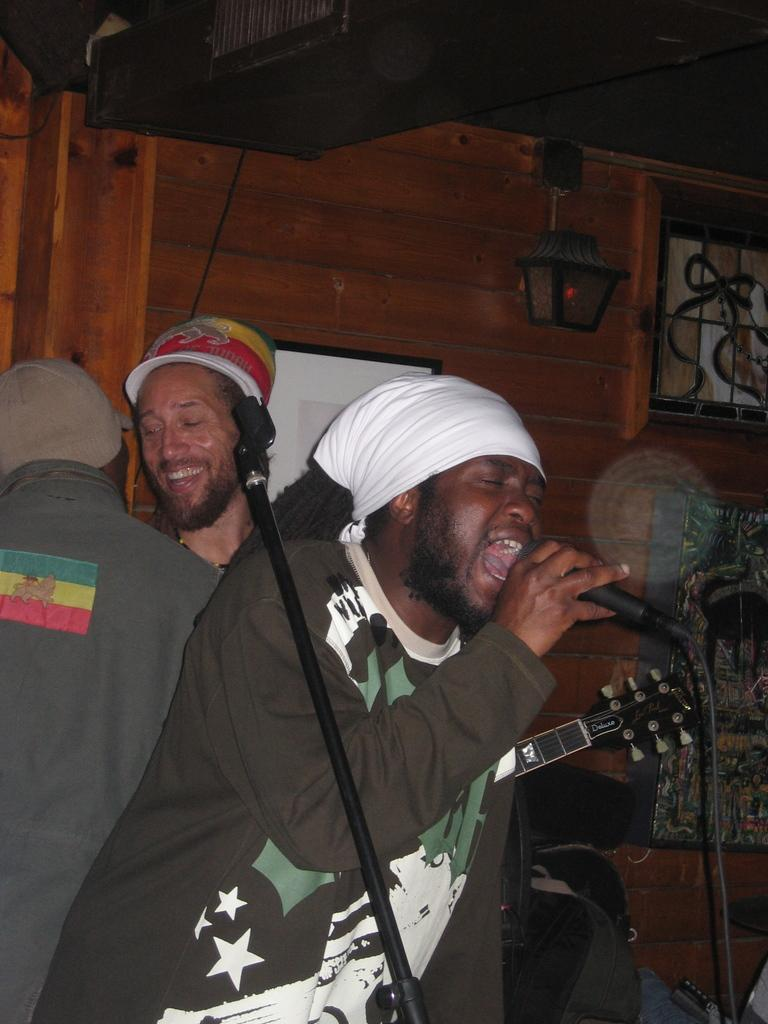How many people are in the image? There are three people in the image. What is one person doing in the image? One person is standing and singing. What object is the person singing holding? The person singing is holding a microphone. How does the other person appear in the image? The other person is smiling. What can be seen in the background of the image? There is a light visible in the background. What is the name of the mountain in the image? There is no mountain present in the image. How does the person walking in the image move? There is no person walking in the image; the person singing is standing. 